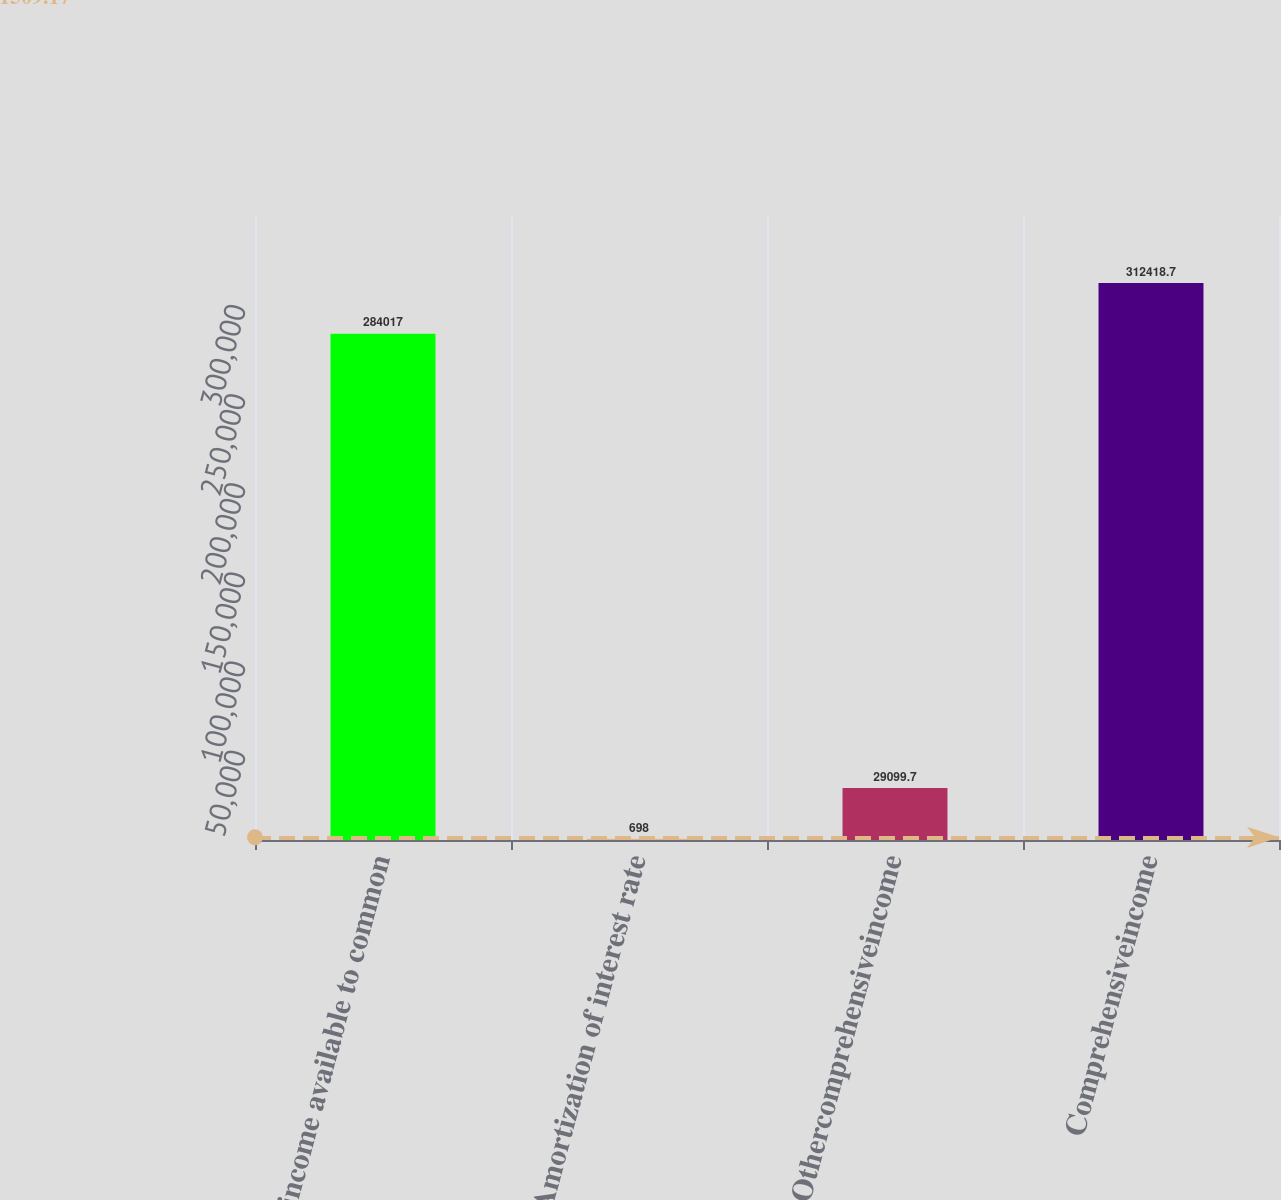<chart> <loc_0><loc_0><loc_500><loc_500><bar_chart><fcel>Net income available to common<fcel>Amortization of interest rate<fcel>Othercomprehensiveincome<fcel>Comprehensiveincome<nl><fcel>284017<fcel>698<fcel>29099.7<fcel>312419<nl></chart> 